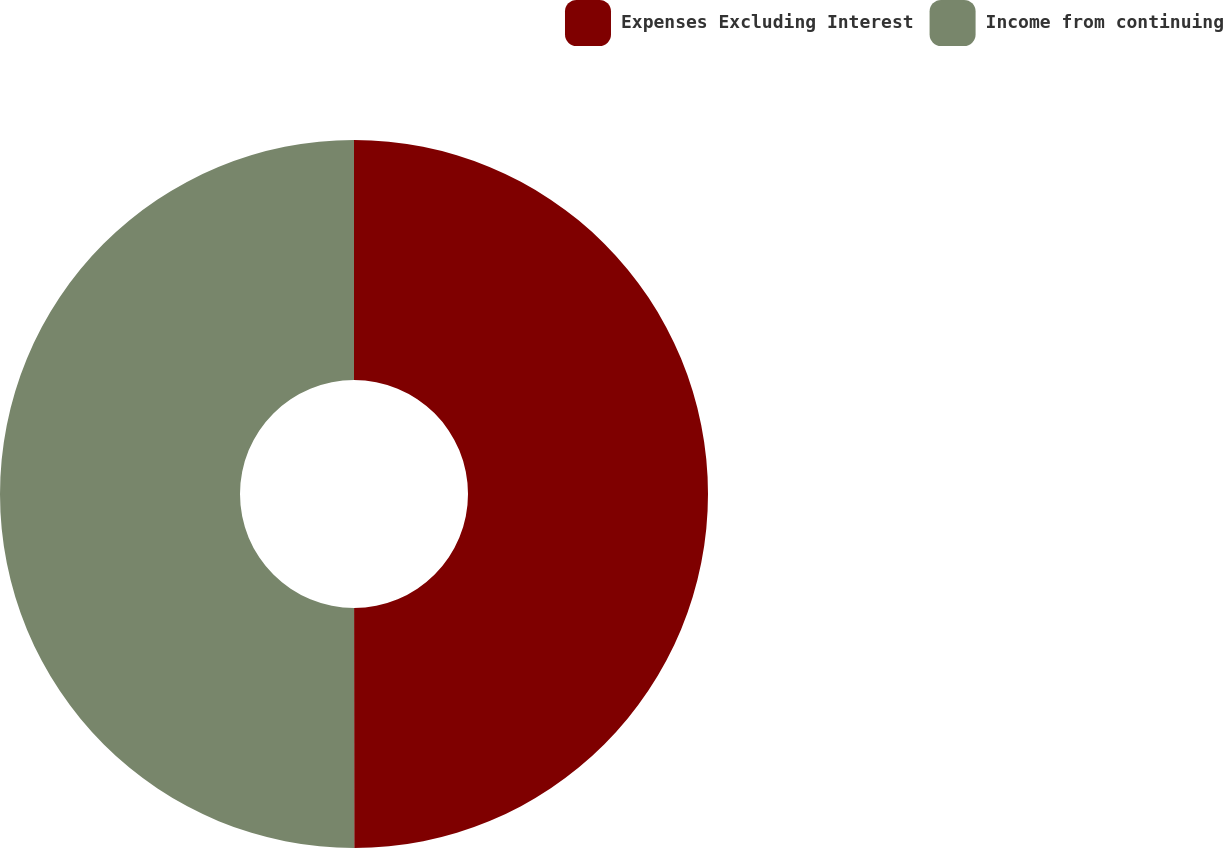<chart> <loc_0><loc_0><loc_500><loc_500><pie_chart><fcel>Expenses Excluding Interest<fcel>Income from continuing<nl><fcel>49.99%<fcel>50.01%<nl></chart> 